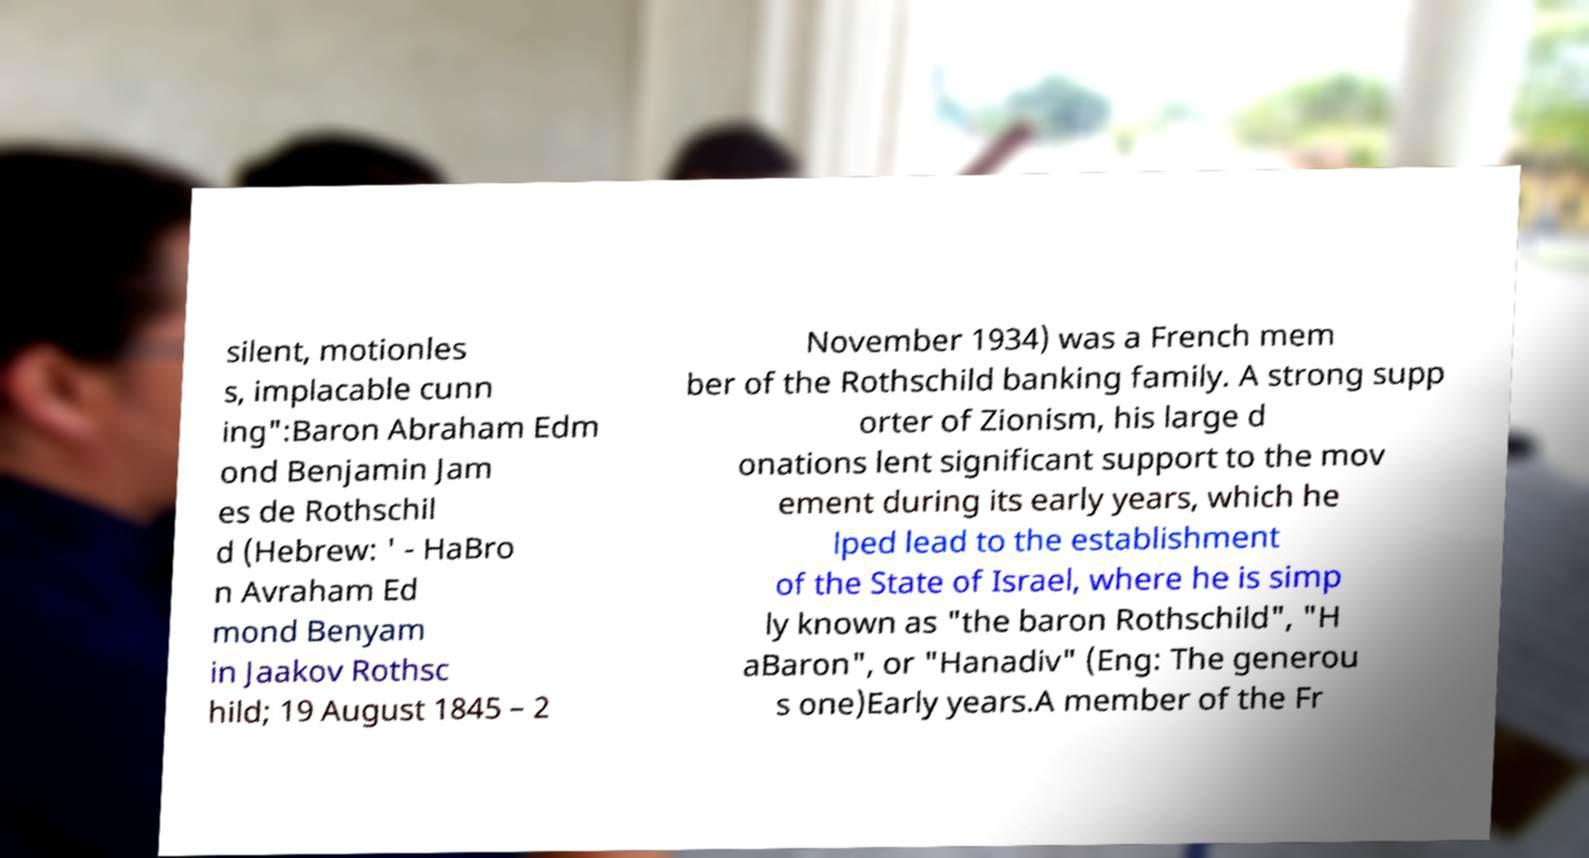Please read and relay the text visible in this image. What does it say? silent, motionles s, implacable cunn ing":Baron Abraham Edm ond Benjamin Jam es de Rothschil d (Hebrew: ' - HaBro n Avraham Ed mond Benyam in Jaakov Rothsc hild; 19 August 1845 – 2 November 1934) was a French mem ber of the Rothschild banking family. A strong supp orter of Zionism, his large d onations lent significant support to the mov ement during its early years, which he lped lead to the establishment of the State of Israel, where he is simp ly known as "the baron Rothschild", "H aBaron", or "Hanadiv" (Eng: The generou s one)Early years.A member of the Fr 